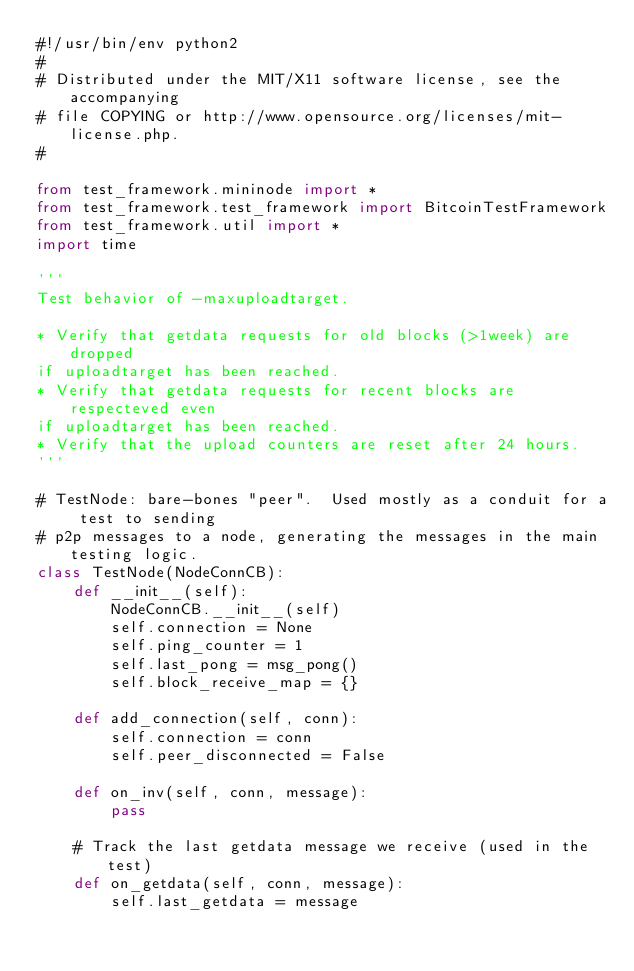Convert code to text. <code><loc_0><loc_0><loc_500><loc_500><_Python_>#!/usr/bin/env python2
#
# Distributed under the MIT/X11 software license, see the accompanying
# file COPYING or http://www.opensource.org/licenses/mit-license.php.
#

from test_framework.mininode import *
from test_framework.test_framework import BitcoinTestFramework
from test_framework.util import *
import time

'''
Test behavior of -maxuploadtarget.

* Verify that getdata requests for old blocks (>1week) are dropped
if uploadtarget has been reached.
* Verify that getdata requests for recent blocks are respecteved even
if uploadtarget has been reached.
* Verify that the upload counters are reset after 24 hours.
'''

# TestNode: bare-bones "peer".  Used mostly as a conduit for a test to sending
# p2p messages to a node, generating the messages in the main testing logic.
class TestNode(NodeConnCB):
    def __init__(self):
        NodeConnCB.__init__(self)
        self.connection = None
        self.ping_counter = 1
        self.last_pong = msg_pong()
        self.block_receive_map = {}

    def add_connection(self, conn):
        self.connection = conn
        self.peer_disconnected = False

    def on_inv(self, conn, message):
        pass

    # Track the last getdata message we receive (used in the test)
    def on_getdata(self, conn, message):
        self.last_getdata = message
</code> 